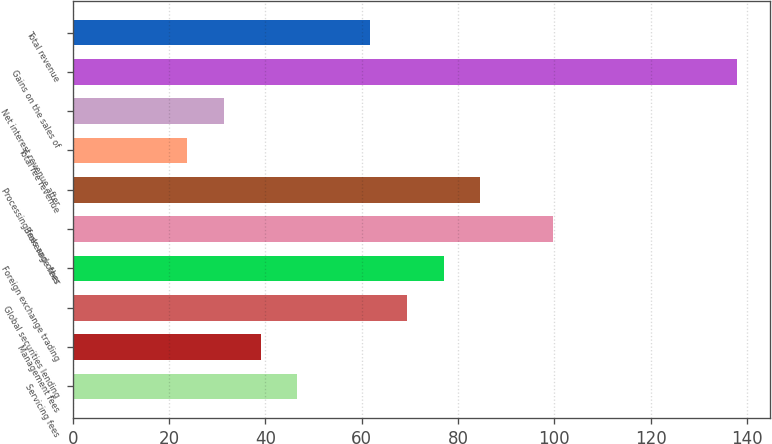Convert chart. <chart><loc_0><loc_0><loc_500><loc_500><bar_chart><fcel>Servicing fees<fcel>Management fees<fcel>Global securities lending<fcel>Foreign exchange trading<fcel>Brokerage fees<fcel>Processing fees and other<fcel>Total fee revenue<fcel>Net interest revenue after<fcel>Gains on the sales of<fcel>Total revenue<nl><fcel>46.6<fcel>39<fcel>69.4<fcel>77<fcel>99.8<fcel>84.6<fcel>23.8<fcel>31.4<fcel>137.8<fcel>61.8<nl></chart> 